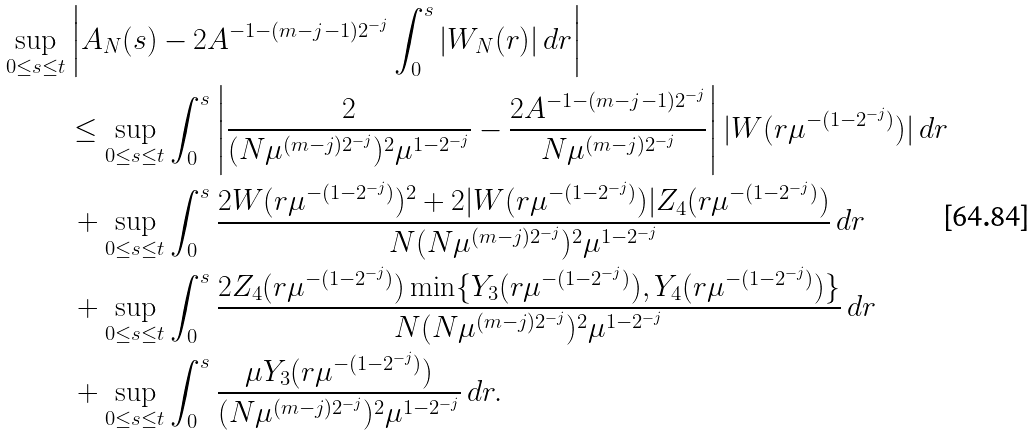<formula> <loc_0><loc_0><loc_500><loc_500>\sup _ { 0 \leq s \leq t } & \left | A _ { N } ( s ) - 2 A ^ { - 1 - ( m - j - 1 ) 2 ^ { - j } } \int _ { 0 } ^ { s } | W _ { N } ( r ) | \, d r \right | \\ & \leq \sup _ { 0 \leq s \leq t } \int _ { 0 } ^ { s } \left | \frac { 2 } { ( N \mu ^ { ( m - j ) 2 ^ { - j } } ) ^ { 2 } \mu ^ { 1 - 2 ^ { - j } } } - \frac { 2 A ^ { - 1 - ( m - j - 1 ) 2 ^ { - j } } } { N \mu ^ { ( m - j ) 2 ^ { - j } } } \right | | W ( r \mu ^ { - ( 1 - 2 ^ { - j } ) } ) | \, d r \\ & \, + \sup _ { 0 \leq s \leq t } \int _ { 0 } ^ { s } \frac { 2 W ( r \mu ^ { - ( 1 - 2 ^ { - j } ) } ) ^ { 2 } + 2 | W ( r \mu ^ { - ( 1 - 2 ^ { - j } ) } ) | Z _ { 4 } ( r \mu ^ { - ( 1 - 2 ^ { - j } ) } ) } { N ( N \mu ^ { ( m - j ) 2 ^ { - j } } ) ^ { 2 } \mu ^ { 1 - 2 ^ { - j } } } \, d r \\ & \, + \sup _ { 0 \leq s \leq t } \int _ { 0 } ^ { s } \frac { 2 Z _ { 4 } ( r \mu ^ { - ( 1 - 2 ^ { - j } ) } ) \min \{ Y _ { 3 } ( r \mu ^ { - ( 1 - 2 ^ { - j } ) } ) , Y _ { 4 } ( r \mu ^ { - ( 1 - 2 ^ { - j } ) } ) \} } { N ( N \mu ^ { ( m - j ) 2 ^ { - j } } ) ^ { 2 } \mu ^ { 1 - 2 ^ { - j } } } \, d r \\ & \, + \sup _ { 0 \leq s \leq t } \int _ { 0 } ^ { s } \frac { \mu Y _ { 3 } ( r \mu ^ { - ( 1 - 2 ^ { - j } ) } ) } { ( N \mu ^ { ( m - j ) 2 ^ { - j } } ) ^ { 2 } \mu ^ { 1 - 2 ^ { - j } } } \, d r .</formula> 